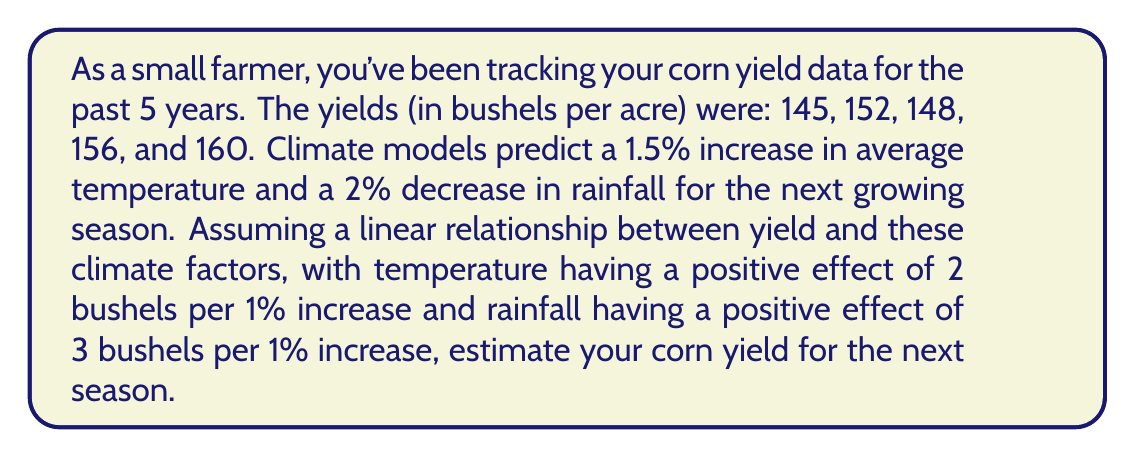Can you answer this question? To solve this problem, we'll follow these steps:

1. Calculate the trend in yield based on historical data:
   Let's find the average year-over-year increase in yield.
   $$ \text{Average increase} = \frac{(152-145) + (148-152) + (156-148) + (160-156)}{4} = 3.75 \text{ bushels/year} $$

2. Project the yield for next year based on the trend:
   $$ \text{Projected yield} = 160 + 3.75 = 163.75 \text{ bushels/acre} $$

3. Adjust for climate changes:
   - Temperature effect: $1.5\% \times 2 \text{ bushels/1%} = 3 \text{ bushels/acre increase}$
   - Rainfall effect: $-2\% \times 3 \text{ bushels/1%} = -6 \text{ bushels/acre decrease}$
   
   Net climate effect: $3 - 6 = -3 \text{ bushels/acre}$

4. Calculate the final estimated yield:
   $$ \text{Estimated yield} = 163.75 - 3 = 160.75 \text{ bushels/acre} $$
Answer: The estimated corn yield for the next season is 160.75 bushels per acre. 